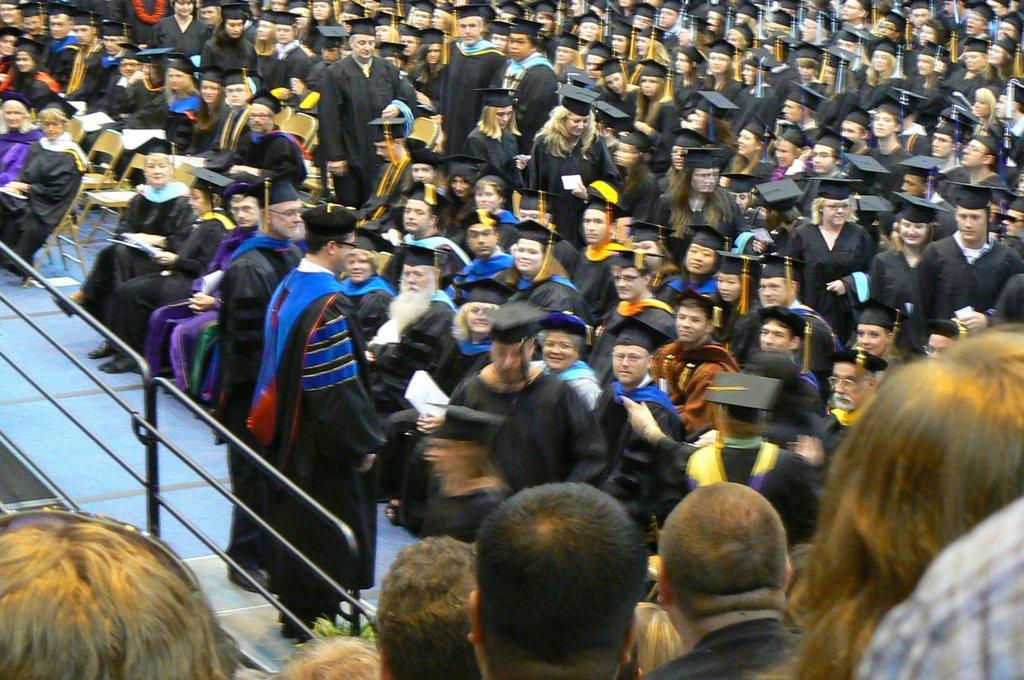How would you summarize this image in a sentence or two? In this picture I can see a number of people sitting on the chair with academic uniform. I can see a few people standing with the academic uniform. I can see the metal grill fence on the left side. 